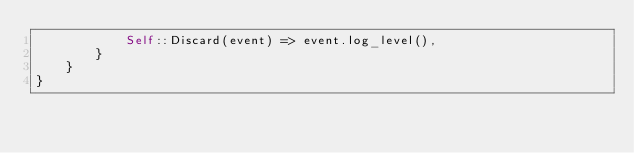<code> <loc_0><loc_0><loc_500><loc_500><_Rust_>            Self::Discard(event) => event.log_level(),
        }
    }
}
</code> 